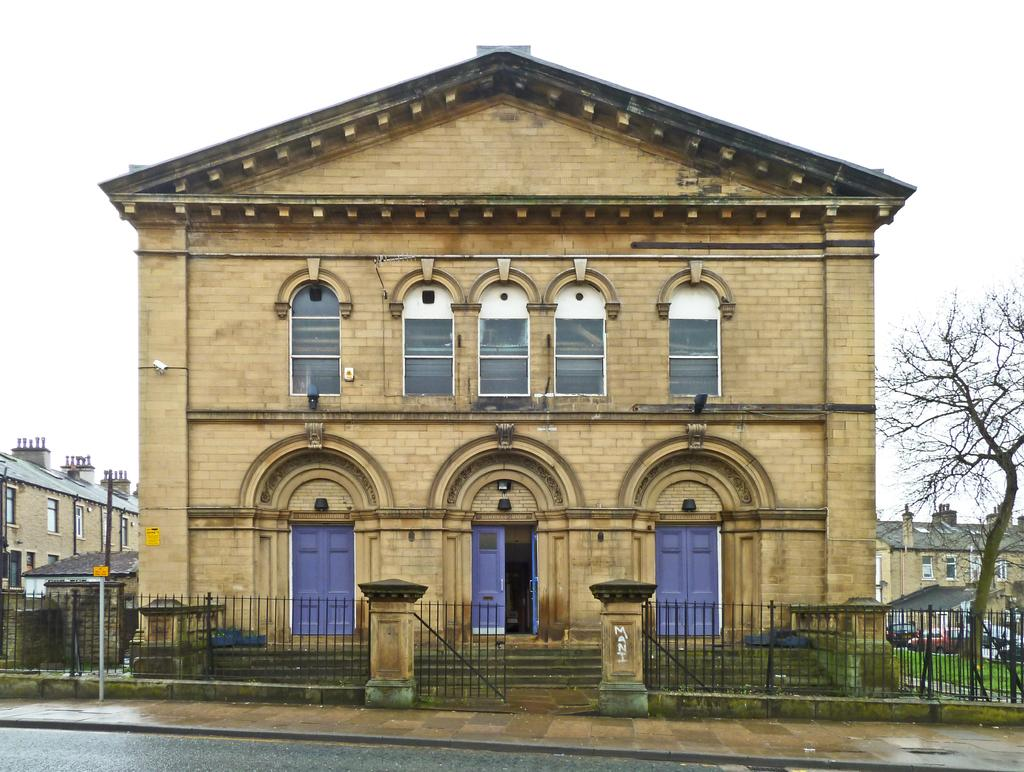What is the main subject in the center of the image? There is a house in the center of the image. What else can be seen in the image besides the house? There are vehicles in the image. What is visible in the background of the image? There are houses, a tree, and the sky visible in the background of the image. How many legs does the stew have in the image? There is no stew present in the image, so it does not have any legs. 